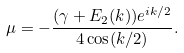Convert formula to latex. <formula><loc_0><loc_0><loc_500><loc_500>\mu = - \frac { ( \gamma + E _ { 2 } ( k ) ) e ^ { i k / 2 } } { 4 \cos ( k / 2 ) } .</formula> 